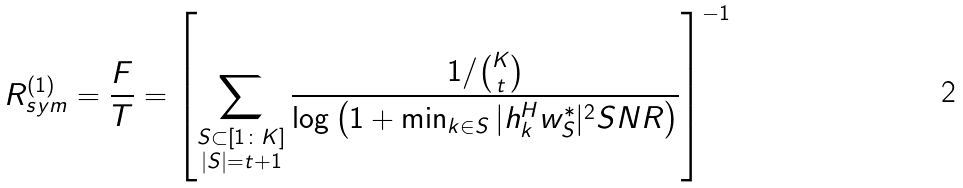<formula> <loc_0><loc_0><loc_500><loc_500>R _ { s y m } ^ { ( 1 ) } = \frac { F } { T } = \left [ \sum _ { \substack { S \subset [ 1 \colon K ] \\ | S | = t + 1 } } \frac { 1 / { K \choose t } } { \log \left ( 1 + \min _ { k \in S } | h _ { k } ^ { H } w _ { S } ^ { * } | ^ { 2 } S N R \right ) } \right ] ^ { - 1 }</formula> 